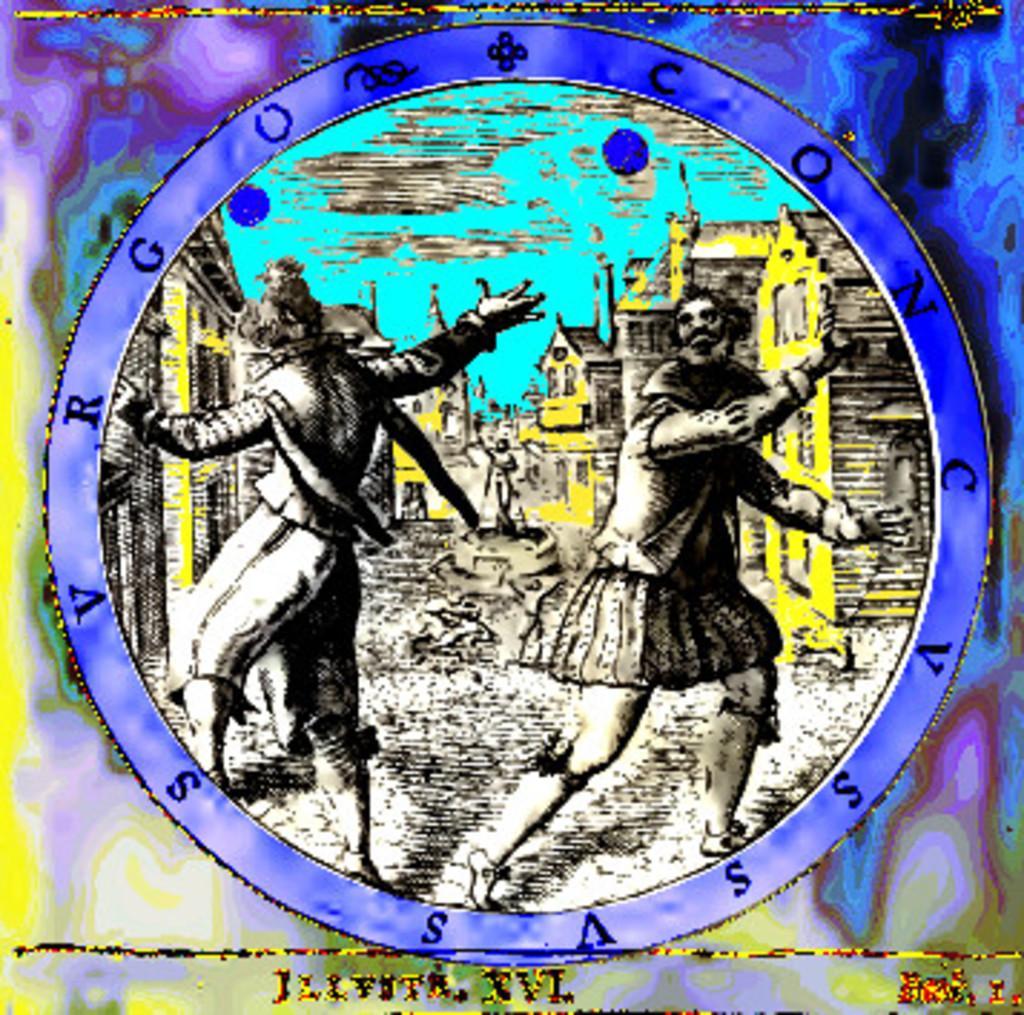Please provide a concise description of this image. In this image I can see a depiction picture where in the front I can see two persons are standing and in the background I can see number of yellow colour buildings. 